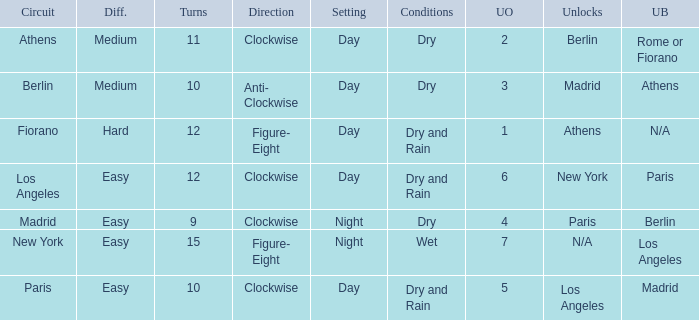What is the setting for the hard difficulty? Day. 